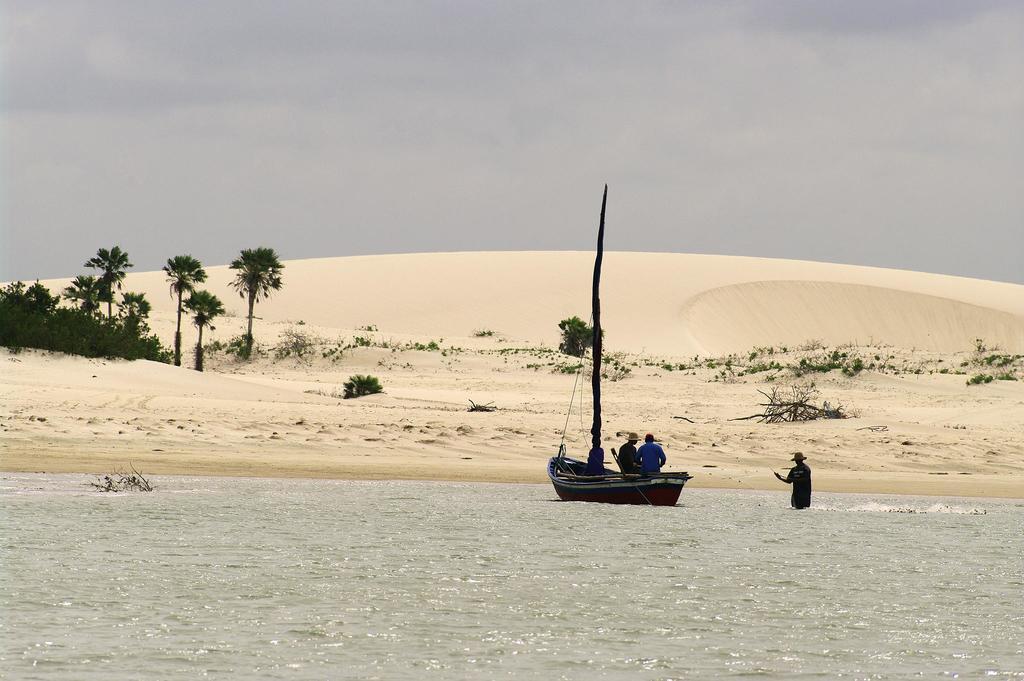Describe this image in one or two sentences. In this image at the bottom there is one lake, in the lake there is one ship and in the ship there are some persons and in the lake there is another person. In the background there is some sand and tree, grass. At the top of the image there is sky. 